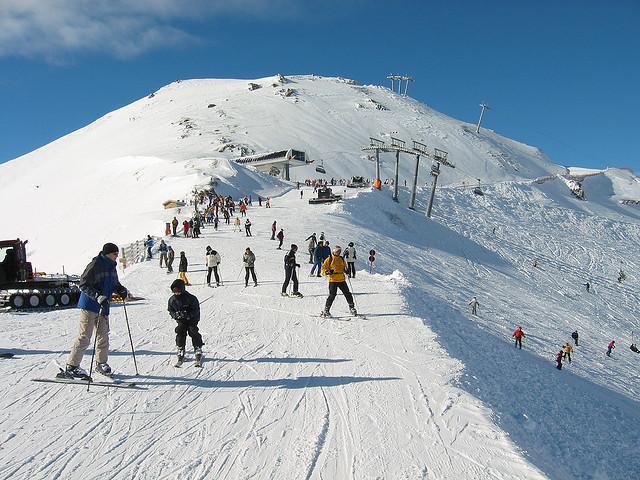How many people are there?
Give a very brief answer. 2. 